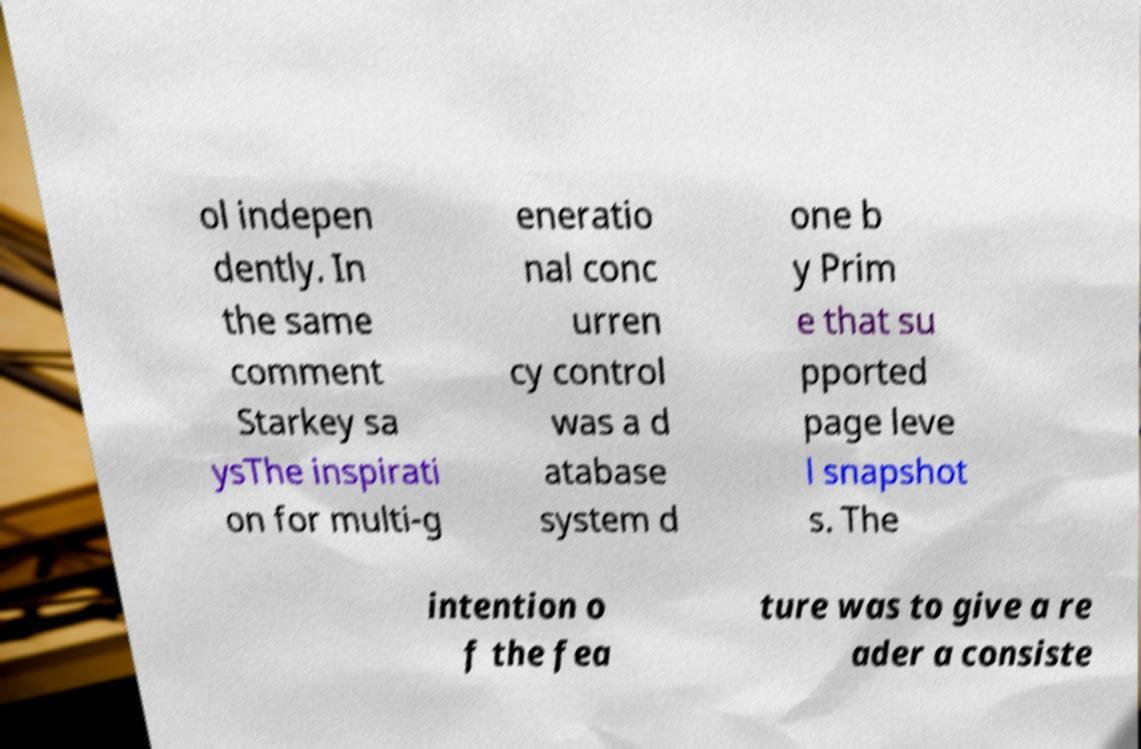Can you accurately transcribe the text from the provided image for me? ol indepen dently. In the same comment Starkey sa ysThe inspirati on for multi-g eneratio nal conc urren cy control was a d atabase system d one b y Prim e that su pported page leve l snapshot s. The intention o f the fea ture was to give a re ader a consiste 